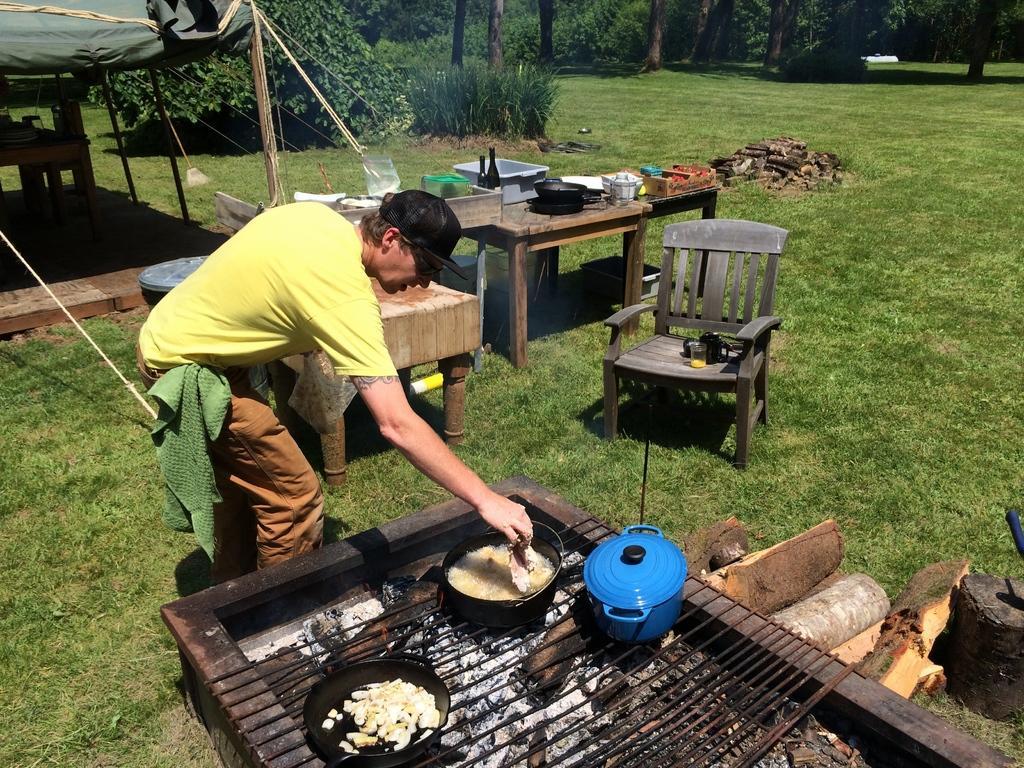Could you give a brief overview of what you see in this image? In this picture there is a man who is wearing cap, t-shirt and holding a meat. Beside him we can see a barbeques table. On that we can see a bucket and other objects. In the background we can see wine bottles, bowls and other objects. On the table there is a wooden chair. At the top we can see trees, plants and grass. On the left there is a tent. 